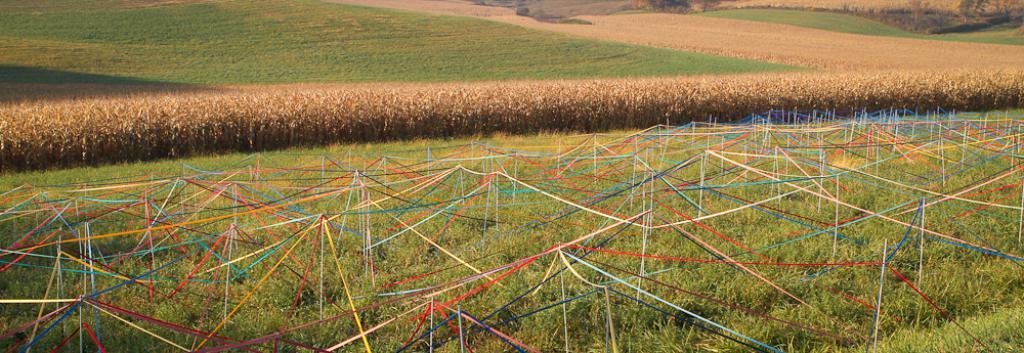In one or two sentences, can you explain what this image depicts? In the picture there are many crops and grass and in a particular area there are plenty of colorful ribbons above the grass. 